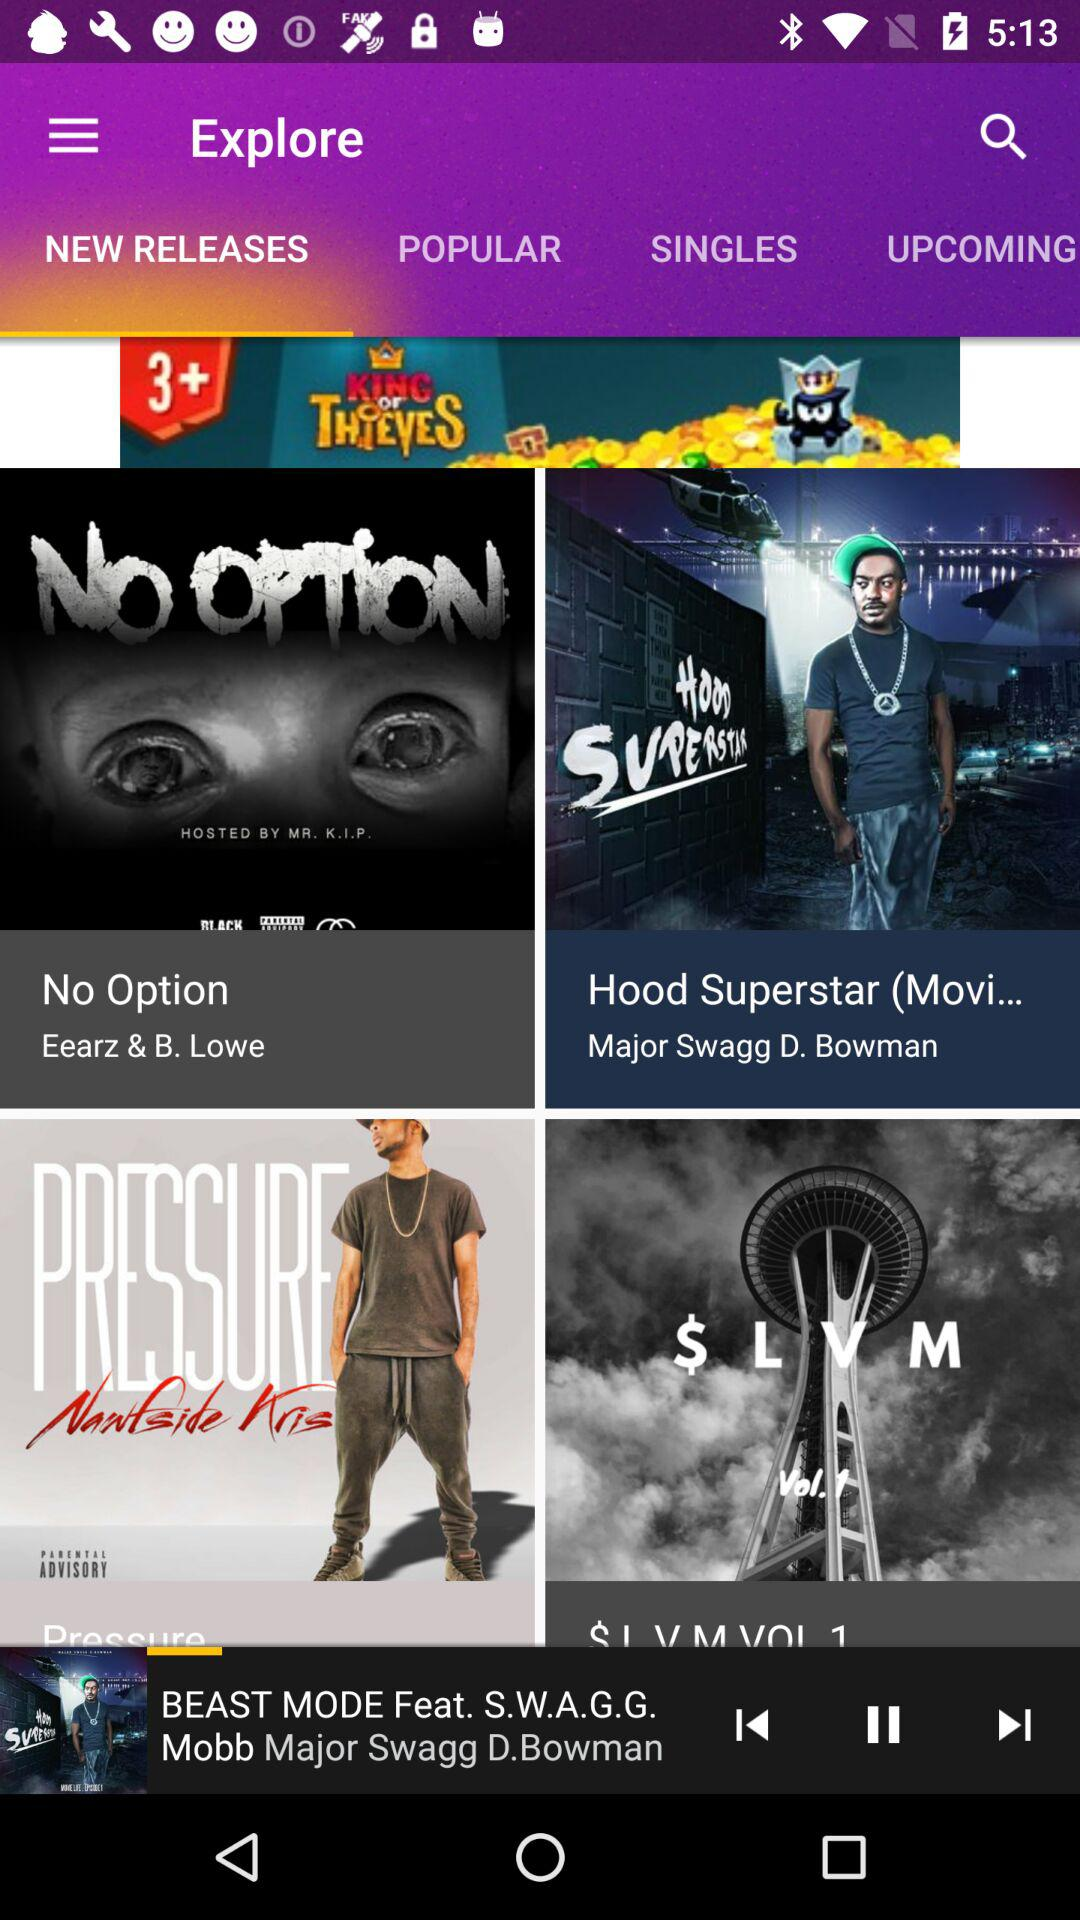Which tab is selected? The selected tab is "NEW RELEASES". 